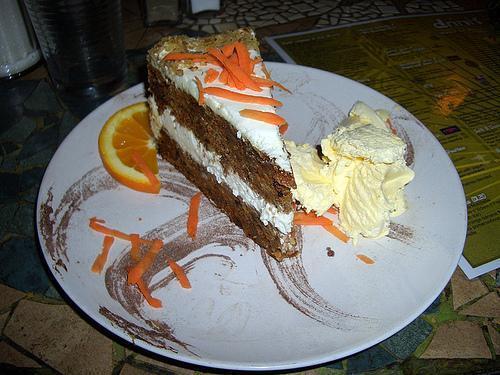How many cups can you see?
Give a very brief answer. 2. 